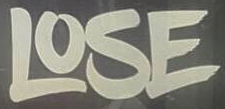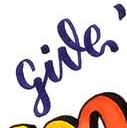Read the text from these images in sequence, separated by a semicolon. LOSE; give 